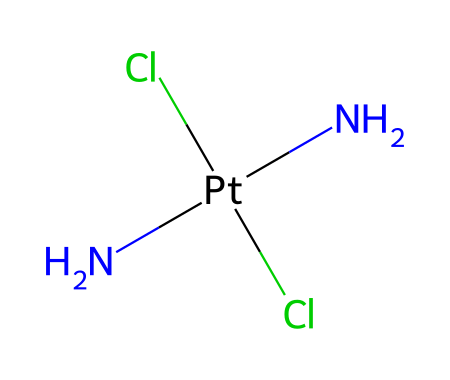What is the central metal atom in cisplatin? The structure shows a platinum atom (Pt) at the center of the coordination complex, signified by its position in the chemical formula.
Answer: platinum How many chlorine atoms are present in cisplatin? In the SMILES representation, there are two 'Cl' indicating the presence of two chlorine atoms attached to the platinum atom.
Answer: 2 What type of ligands are associated with the central metal in cisplatin? The structure contains two chlorine ligands and two amine groups (represented by 'N'), which are typical for coordination compounds.
Answer: amine and chloride What is the stereochemistry of cisplatin? The 'cis' designation refers to the positioning of the ligands around the platinum, meaning that the two amine groups and the two chloride ligands are adjacent to each other.
Answer: cis Which functional groups are present in cisplatin? The presence of nitrogen atoms (amine groups) and chlorine atoms indicates that cisplatin contains amine and halide functional groups.
Answer: amine and halide How many coordination sites does the platinum atom have in cisplatin? The platinum atom in cisplatin is coordinated by four atoms total (two from amine groups and two from chloride), which means it has four coordination sites.
Answer: 4 What type of organometallic structure is represented by the arrangement in cisplatin? The arrangement is characterized by a square planar geometry around the platinum, as commonly found in organometallic complexes with d8 metal centers.
Answer: square planar 